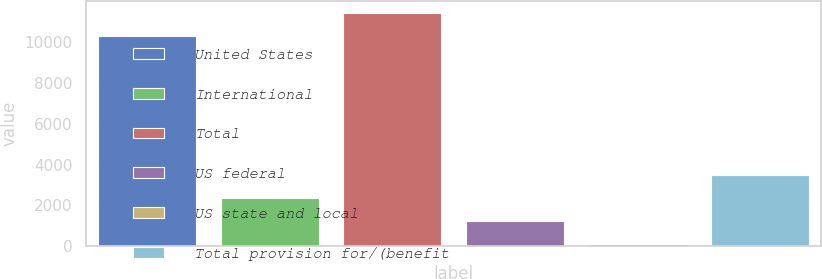<chart> <loc_0><loc_0><loc_500><loc_500><bar_chart><fcel>United States<fcel>International<fcel>Total<fcel>US federal<fcel>US state and local<fcel>Total provision for/(benefit<nl><fcel>10305<fcel>2371.4<fcel>11423.7<fcel>1252.7<fcel>134<fcel>3490.1<nl></chart> 